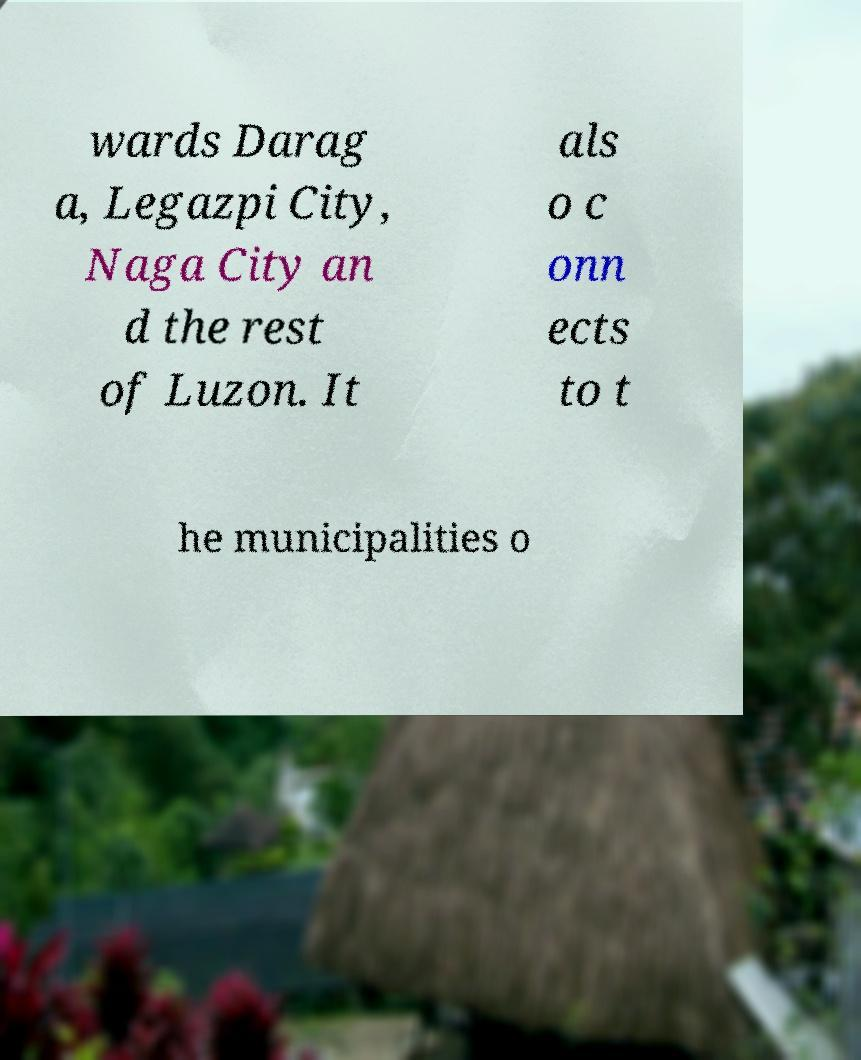For documentation purposes, I need the text within this image transcribed. Could you provide that? wards Darag a, Legazpi City, Naga City an d the rest of Luzon. It als o c onn ects to t he municipalities o 